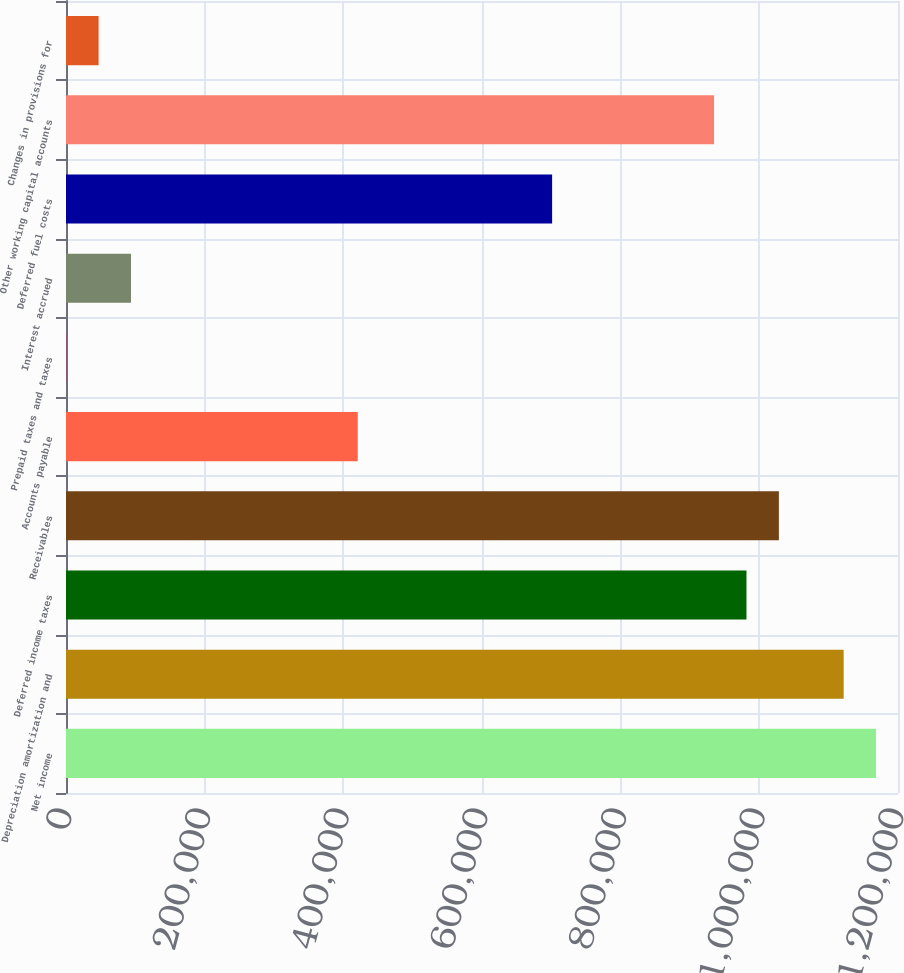<chart> <loc_0><loc_0><loc_500><loc_500><bar_chart><fcel>Net income<fcel>Depreciation amortization and<fcel>Deferred income taxes<fcel>Receivables<fcel>Accounts payable<fcel>Prepaid taxes and taxes<fcel>Interest accrued<fcel>Deferred fuel costs<fcel>Other working capital accounts<fcel>Changes in provisions for<nl><fcel>1.16835e+06<fcel>1.12163e+06<fcel>981460<fcel>1.02818e+06<fcel>420797<fcel>300<fcel>93743.8<fcel>701128<fcel>934738<fcel>47021.9<nl></chart> 